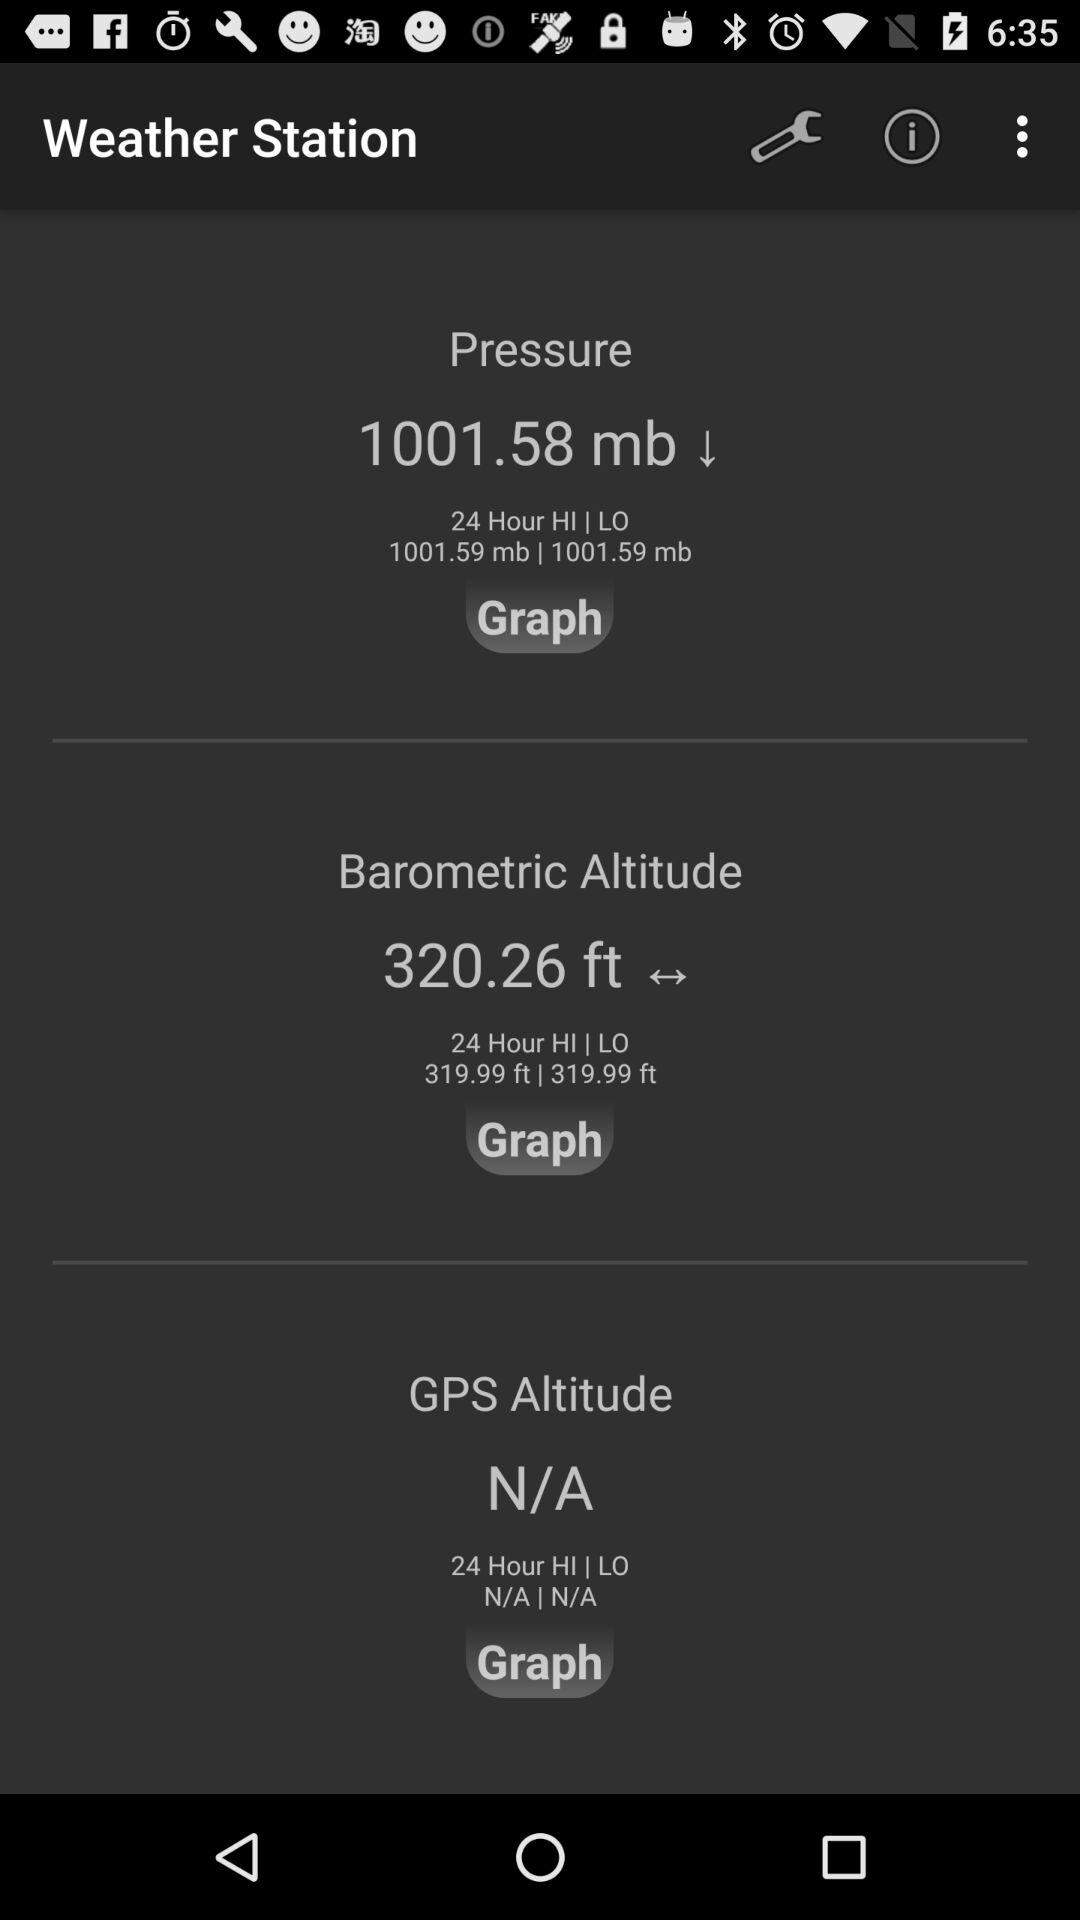Which pressure reading is higher, the pressure reading or the barometric altitude reading?
Answer the question using a single word or phrase. Pressure 